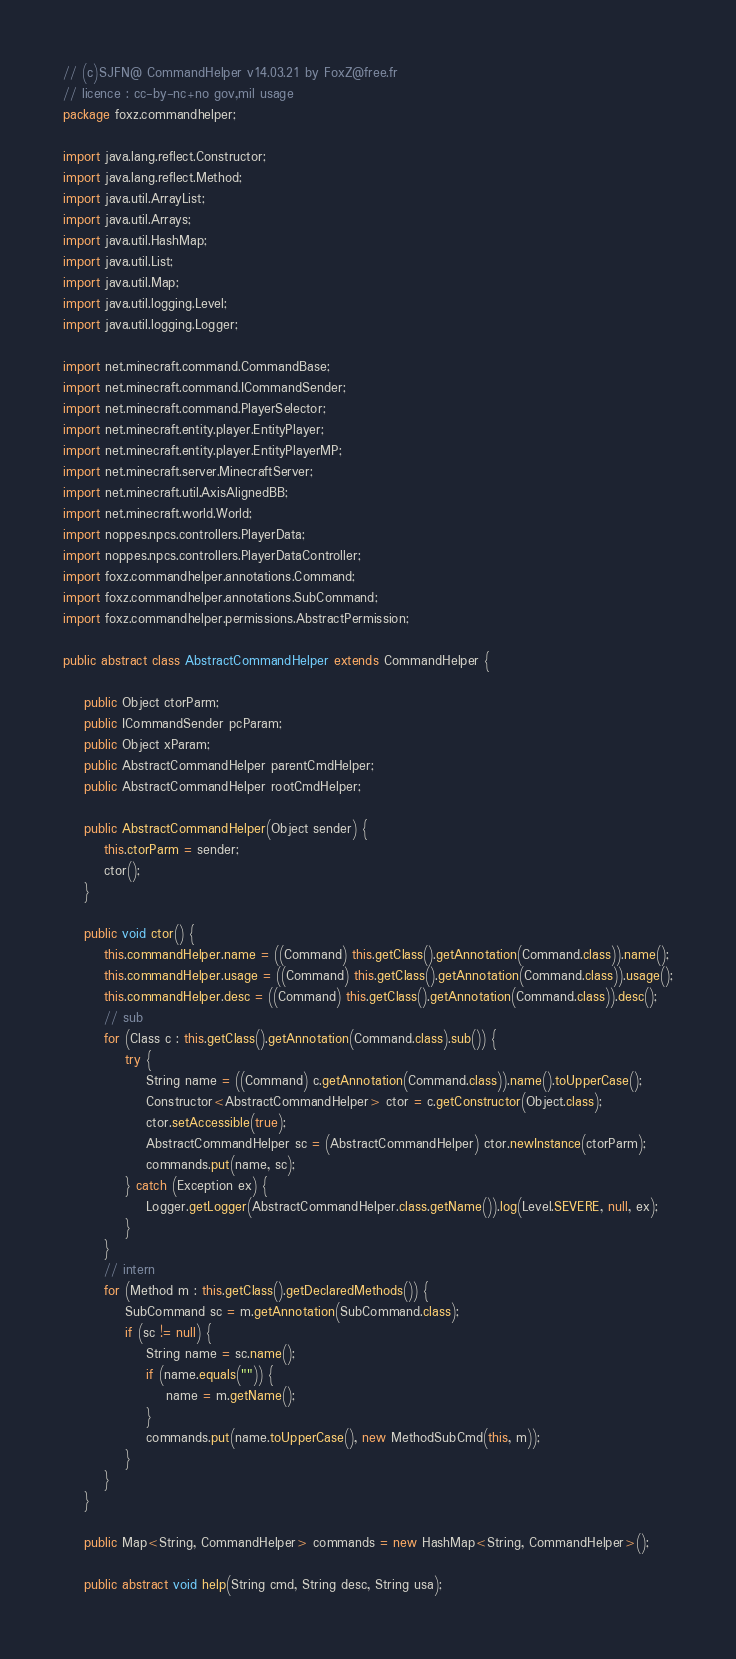Convert code to text. <code><loc_0><loc_0><loc_500><loc_500><_Java_>// (c)SJFN@ CommandHelper v14.03.21 by FoxZ@free.fr
// licence : cc-by-nc+no gov,mil usage
package foxz.commandhelper;

import java.lang.reflect.Constructor;
import java.lang.reflect.Method;
import java.util.ArrayList;
import java.util.Arrays;
import java.util.HashMap;
import java.util.List;
import java.util.Map;
import java.util.logging.Level;
import java.util.logging.Logger;

import net.minecraft.command.CommandBase;
import net.minecraft.command.ICommandSender;
import net.minecraft.command.PlayerSelector;
import net.minecraft.entity.player.EntityPlayer;
import net.minecraft.entity.player.EntityPlayerMP;
import net.minecraft.server.MinecraftServer;
import net.minecraft.util.AxisAlignedBB;
import net.minecraft.world.World;
import noppes.npcs.controllers.PlayerData;
import noppes.npcs.controllers.PlayerDataController;
import foxz.commandhelper.annotations.Command;
import foxz.commandhelper.annotations.SubCommand;
import foxz.commandhelper.permissions.AbstractPermission;

public abstract class AbstractCommandHelper extends CommandHelper {

    public Object ctorParm;
    public ICommandSender pcParam;
    public Object xParam;
    public AbstractCommandHelper parentCmdHelper;
    public AbstractCommandHelper rootCmdHelper;

    public AbstractCommandHelper(Object sender) {
        this.ctorParm = sender;
        ctor();
    }

    public void ctor() {
        this.commandHelper.name = ((Command) this.getClass().getAnnotation(Command.class)).name();
        this.commandHelper.usage = ((Command) this.getClass().getAnnotation(Command.class)).usage();
        this.commandHelper.desc = ((Command) this.getClass().getAnnotation(Command.class)).desc();
        // sub
        for (Class c : this.getClass().getAnnotation(Command.class).sub()) {
            try {
                String name = ((Command) c.getAnnotation(Command.class)).name().toUpperCase();
                Constructor<AbstractCommandHelper> ctor = c.getConstructor(Object.class);
                ctor.setAccessible(true);
                AbstractCommandHelper sc = (AbstractCommandHelper) ctor.newInstance(ctorParm);
                commands.put(name, sc);
            } catch (Exception ex) {
                Logger.getLogger(AbstractCommandHelper.class.getName()).log(Level.SEVERE, null, ex);
            }
        }
        // intern
        for (Method m : this.getClass().getDeclaredMethods()) {
            SubCommand sc = m.getAnnotation(SubCommand.class);
            if (sc != null) {
                String name = sc.name();
                if (name.equals("")) {
                    name = m.getName();
                }
                commands.put(name.toUpperCase(), new MethodSubCmd(this, m));
            }
        }
    }

    public Map<String, CommandHelper> commands = new HashMap<String, CommandHelper>();

    public abstract void help(String cmd, String desc, String usa);
</code> 